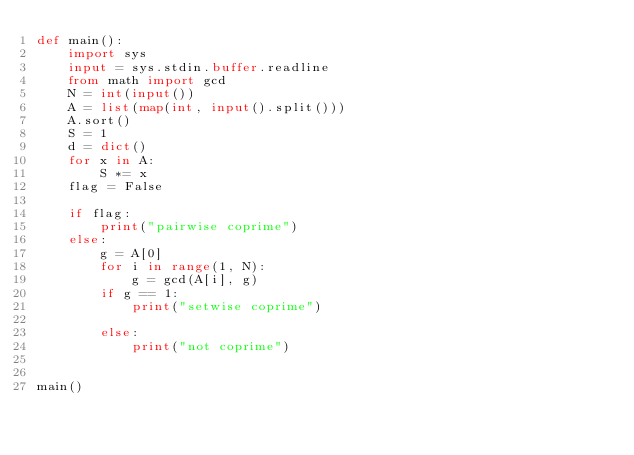<code> <loc_0><loc_0><loc_500><loc_500><_Python_>def main():
    import sys
    input = sys.stdin.buffer.readline
    from math import gcd
    N = int(input())
    A = list(map(int, input().split()))
    A.sort()
    S = 1
    d = dict()
    for x in A:
        S *= x
    flag = False

    if flag:
        print("pairwise coprime")
    else:
        g = A[0]
        for i in range(1, N):
            g = gcd(A[i], g)
        if g == 1:
            print("setwise coprime")

        else:
            print("not coprime")


main()
</code> 